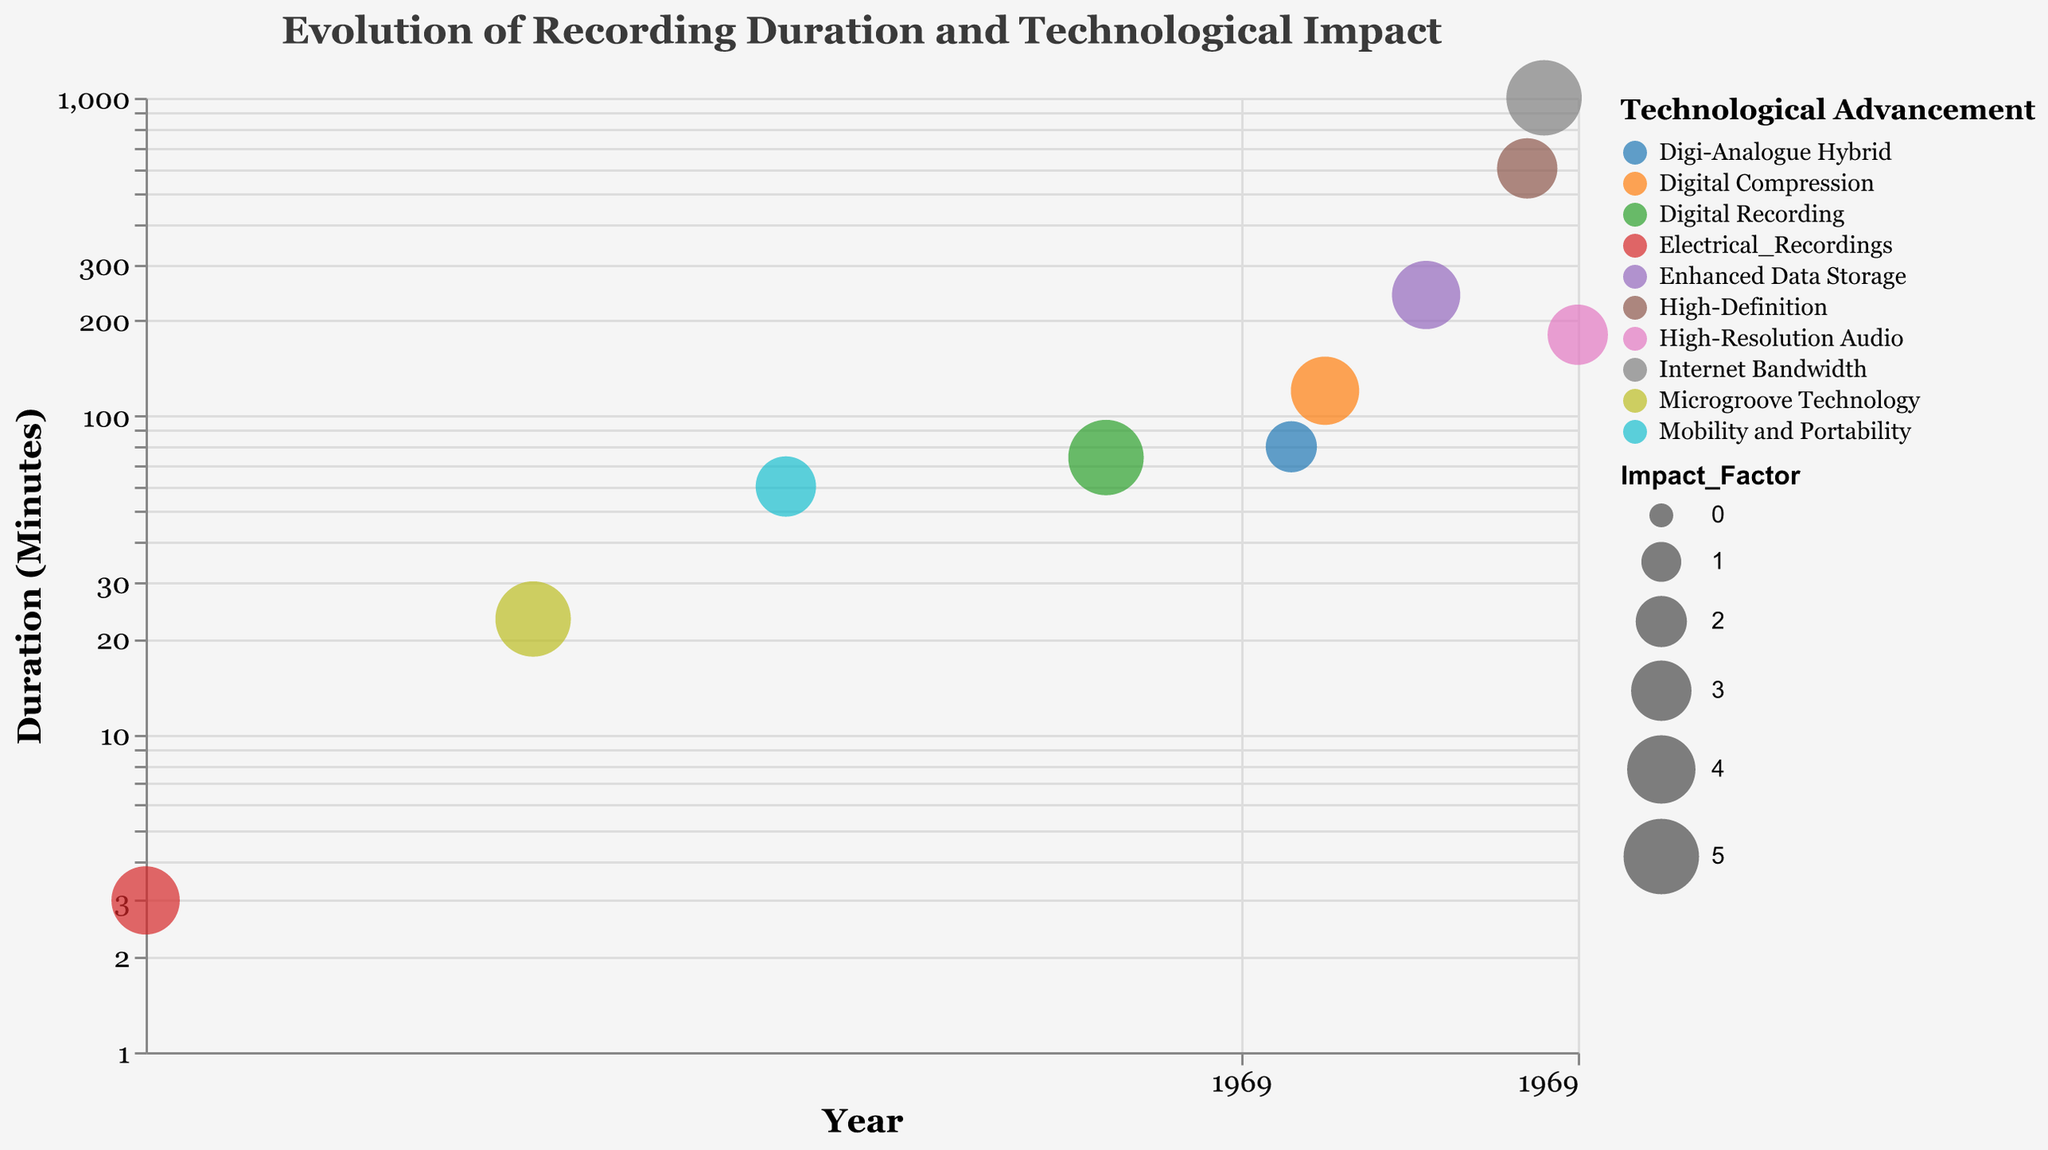What is the title of the figure? The title of the figure is clearly displayed at the top of the chart. Reading the title directly from the top of the figure gives us the answer.
Answer: Evolution of Recording Duration and Technological Impact How many types of recording technologies are depicted in the figure? Each recording technology type is represented by a distinct bubble color in the chart. Counting the different bubble colors gives us the answer.
Answer: 10 What technological advancement has the longest recording duration? The duration on the y-axis is plotted logarithmically, and the bubble with the highest y-position represents the longest recording duration. Identifying this bubble and checking its technological advancement gives us the answer.
Answer: Internet Bandwidth (Streaming) Which recording type has the highest impact factor? The size of the bubbles illustrates the impact factor. Identifying the largest bubble and checking its recording type provides the solution.
Answer: Compact_Disc (CD) and Streaming (both have Impact Factor = 5) What is the duration difference between the Compact Cassette and the Compact Disc (CD)? The duration for Compact Cassette (1963) is 60 minutes, and for Compact Disc (CD) (1982) is 74 minutes. The difference is calculated by subtracting the smaller duration from the larger duration.
Answer: 14 minutes Which recording type was introduced in the year 1982? The x-axis represents years, and locating the bubble at the position of 1982 helps identify the recording type associated with that year.
Answer: Compact_Disc (CD) What is the impact factor of the longest recording duration technology? After determining that Streaming has the longest recording duration, we look at its corresponding bubble and note the impact factor.
Answer: 5 How did the recording duration change from Vinyl Record in 1925 to Long-Playing Record (LP) in 1948? The duration for Vinyl Record (1925) is 3 minutes, and for Long-Playing Record (LP) (1948) is 23 minutes. The change is calculated by subtracting the former from the latter.
Answer: Increase of 20 minutes Which technological advancement occurred closest to the year 2000? Locating the bubble closest to the year 2000 on the x-axis and identifying the technological advancement associated with it gives the answer.
Answer: Digital Compression (MP3 File, 1995) 